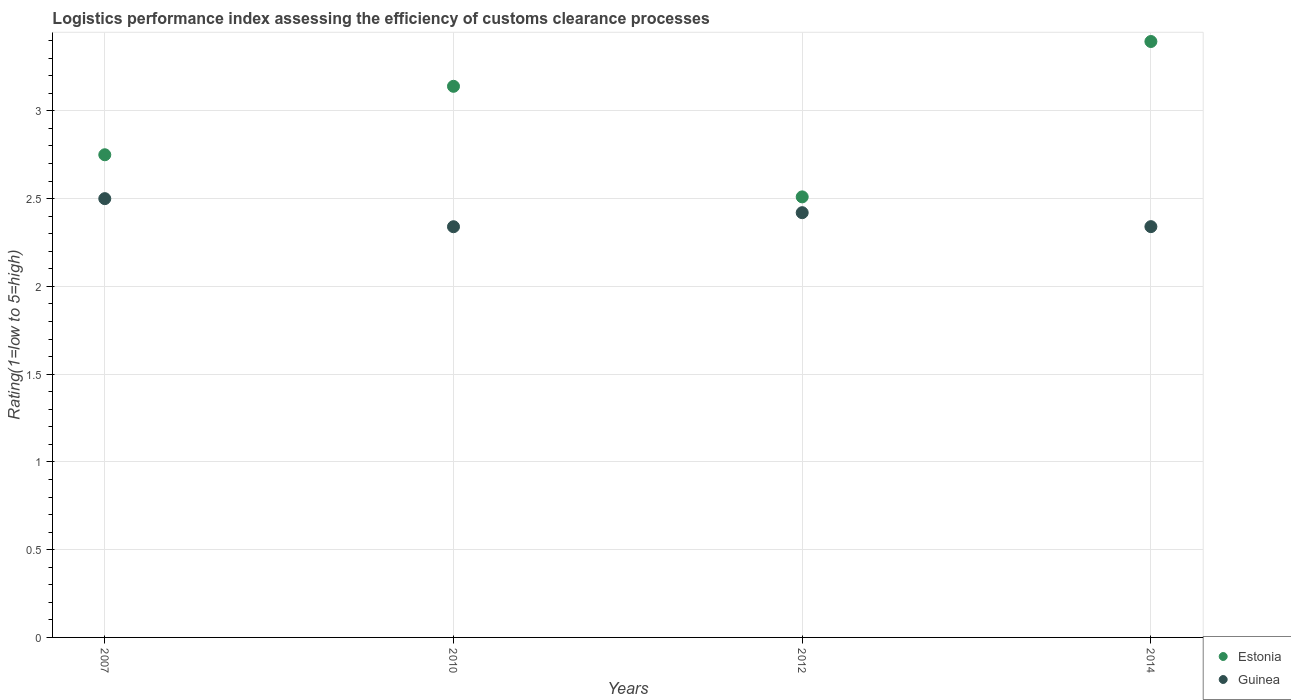How many different coloured dotlines are there?
Ensure brevity in your answer.  2. What is the Logistic performance index in Estonia in 2012?
Offer a terse response. 2.51. Across all years, what is the maximum Logistic performance index in Guinea?
Your answer should be very brief. 2.5. Across all years, what is the minimum Logistic performance index in Guinea?
Your answer should be compact. 2.34. In which year was the Logistic performance index in Guinea maximum?
Keep it short and to the point. 2007. What is the total Logistic performance index in Guinea in the graph?
Keep it short and to the point. 9.6. What is the difference between the Logistic performance index in Guinea in 2012 and that in 2014?
Your answer should be very brief. 0.08. What is the difference between the Logistic performance index in Guinea in 2010 and the Logistic performance index in Estonia in 2007?
Offer a very short reply. -0.41. What is the average Logistic performance index in Estonia per year?
Your response must be concise. 2.95. In the year 2012, what is the difference between the Logistic performance index in Estonia and Logistic performance index in Guinea?
Offer a very short reply. 0.09. What is the ratio of the Logistic performance index in Estonia in 2007 to that in 2010?
Your answer should be compact. 0.88. Is the difference between the Logistic performance index in Estonia in 2010 and 2014 greater than the difference between the Logistic performance index in Guinea in 2010 and 2014?
Provide a succinct answer. No. What is the difference between the highest and the second highest Logistic performance index in Guinea?
Your answer should be compact. 0.08. What is the difference between the highest and the lowest Logistic performance index in Guinea?
Keep it short and to the point. 0.16. In how many years, is the Logistic performance index in Guinea greater than the average Logistic performance index in Guinea taken over all years?
Offer a very short reply. 2. Is the Logistic performance index in Estonia strictly greater than the Logistic performance index in Guinea over the years?
Your response must be concise. Yes. How many years are there in the graph?
Offer a terse response. 4. What is the difference between two consecutive major ticks on the Y-axis?
Give a very brief answer. 0.5. Does the graph contain any zero values?
Your answer should be very brief. No. Where does the legend appear in the graph?
Your response must be concise. Bottom right. What is the title of the graph?
Give a very brief answer. Logistics performance index assessing the efficiency of customs clearance processes. What is the label or title of the Y-axis?
Offer a very short reply. Rating(1=low to 5=high). What is the Rating(1=low to 5=high) of Estonia in 2007?
Provide a succinct answer. 2.75. What is the Rating(1=low to 5=high) of Estonia in 2010?
Give a very brief answer. 3.14. What is the Rating(1=low to 5=high) of Guinea in 2010?
Provide a short and direct response. 2.34. What is the Rating(1=low to 5=high) in Estonia in 2012?
Keep it short and to the point. 2.51. What is the Rating(1=low to 5=high) in Guinea in 2012?
Keep it short and to the point. 2.42. What is the Rating(1=low to 5=high) of Estonia in 2014?
Give a very brief answer. 3.4. What is the Rating(1=low to 5=high) of Guinea in 2014?
Provide a short and direct response. 2.34. Across all years, what is the maximum Rating(1=low to 5=high) of Estonia?
Your response must be concise. 3.4. Across all years, what is the maximum Rating(1=low to 5=high) of Guinea?
Your answer should be very brief. 2.5. Across all years, what is the minimum Rating(1=low to 5=high) in Estonia?
Make the answer very short. 2.51. Across all years, what is the minimum Rating(1=low to 5=high) of Guinea?
Make the answer very short. 2.34. What is the total Rating(1=low to 5=high) in Estonia in the graph?
Offer a terse response. 11.8. What is the total Rating(1=low to 5=high) of Guinea in the graph?
Offer a very short reply. 9.6. What is the difference between the Rating(1=low to 5=high) of Estonia in 2007 and that in 2010?
Provide a short and direct response. -0.39. What is the difference between the Rating(1=low to 5=high) of Guinea in 2007 and that in 2010?
Provide a short and direct response. 0.16. What is the difference between the Rating(1=low to 5=high) in Estonia in 2007 and that in 2012?
Provide a short and direct response. 0.24. What is the difference between the Rating(1=low to 5=high) of Estonia in 2007 and that in 2014?
Your answer should be very brief. -0.65. What is the difference between the Rating(1=low to 5=high) in Guinea in 2007 and that in 2014?
Keep it short and to the point. 0.16. What is the difference between the Rating(1=low to 5=high) of Estonia in 2010 and that in 2012?
Your answer should be very brief. 0.63. What is the difference between the Rating(1=low to 5=high) of Guinea in 2010 and that in 2012?
Your response must be concise. -0.08. What is the difference between the Rating(1=low to 5=high) in Estonia in 2010 and that in 2014?
Your answer should be compact. -0.26. What is the difference between the Rating(1=low to 5=high) of Guinea in 2010 and that in 2014?
Keep it short and to the point. -0. What is the difference between the Rating(1=low to 5=high) in Estonia in 2012 and that in 2014?
Your answer should be compact. -0.89. What is the difference between the Rating(1=low to 5=high) of Guinea in 2012 and that in 2014?
Ensure brevity in your answer.  0.08. What is the difference between the Rating(1=low to 5=high) of Estonia in 2007 and the Rating(1=low to 5=high) of Guinea in 2010?
Make the answer very short. 0.41. What is the difference between the Rating(1=low to 5=high) in Estonia in 2007 and the Rating(1=low to 5=high) in Guinea in 2012?
Your answer should be compact. 0.33. What is the difference between the Rating(1=low to 5=high) of Estonia in 2007 and the Rating(1=low to 5=high) of Guinea in 2014?
Provide a short and direct response. 0.41. What is the difference between the Rating(1=low to 5=high) in Estonia in 2010 and the Rating(1=low to 5=high) in Guinea in 2012?
Keep it short and to the point. 0.72. What is the difference between the Rating(1=low to 5=high) in Estonia in 2010 and the Rating(1=low to 5=high) in Guinea in 2014?
Offer a very short reply. 0.8. What is the difference between the Rating(1=low to 5=high) in Estonia in 2012 and the Rating(1=low to 5=high) in Guinea in 2014?
Offer a very short reply. 0.17. What is the average Rating(1=low to 5=high) of Estonia per year?
Provide a succinct answer. 2.95. What is the average Rating(1=low to 5=high) in Guinea per year?
Offer a terse response. 2.4. In the year 2007, what is the difference between the Rating(1=low to 5=high) of Estonia and Rating(1=low to 5=high) of Guinea?
Offer a terse response. 0.25. In the year 2010, what is the difference between the Rating(1=low to 5=high) of Estonia and Rating(1=low to 5=high) of Guinea?
Your answer should be compact. 0.8. In the year 2012, what is the difference between the Rating(1=low to 5=high) in Estonia and Rating(1=low to 5=high) in Guinea?
Give a very brief answer. 0.09. In the year 2014, what is the difference between the Rating(1=low to 5=high) of Estonia and Rating(1=low to 5=high) of Guinea?
Make the answer very short. 1.05. What is the ratio of the Rating(1=low to 5=high) in Estonia in 2007 to that in 2010?
Your answer should be compact. 0.88. What is the ratio of the Rating(1=low to 5=high) in Guinea in 2007 to that in 2010?
Provide a short and direct response. 1.07. What is the ratio of the Rating(1=low to 5=high) of Estonia in 2007 to that in 2012?
Your answer should be compact. 1.1. What is the ratio of the Rating(1=low to 5=high) of Guinea in 2007 to that in 2012?
Your response must be concise. 1.03. What is the ratio of the Rating(1=low to 5=high) in Estonia in 2007 to that in 2014?
Your answer should be compact. 0.81. What is the ratio of the Rating(1=low to 5=high) of Guinea in 2007 to that in 2014?
Give a very brief answer. 1.07. What is the ratio of the Rating(1=low to 5=high) in Estonia in 2010 to that in 2012?
Your answer should be compact. 1.25. What is the ratio of the Rating(1=low to 5=high) of Guinea in 2010 to that in 2012?
Offer a very short reply. 0.97. What is the ratio of the Rating(1=low to 5=high) of Estonia in 2010 to that in 2014?
Provide a short and direct response. 0.92. What is the ratio of the Rating(1=low to 5=high) in Estonia in 2012 to that in 2014?
Offer a terse response. 0.74. What is the ratio of the Rating(1=low to 5=high) of Guinea in 2012 to that in 2014?
Give a very brief answer. 1.03. What is the difference between the highest and the second highest Rating(1=low to 5=high) in Estonia?
Provide a short and direct response. 0.26. What is the difference between the highest and the lowest Rating(1=low to 5=high) of Estonia?
Offer a very short reply. 0.89. What is the difference between the highest and the lowest Rating(1=low to 5=high) of Guinea?
Ensure brevity in your answer.  0.16. 